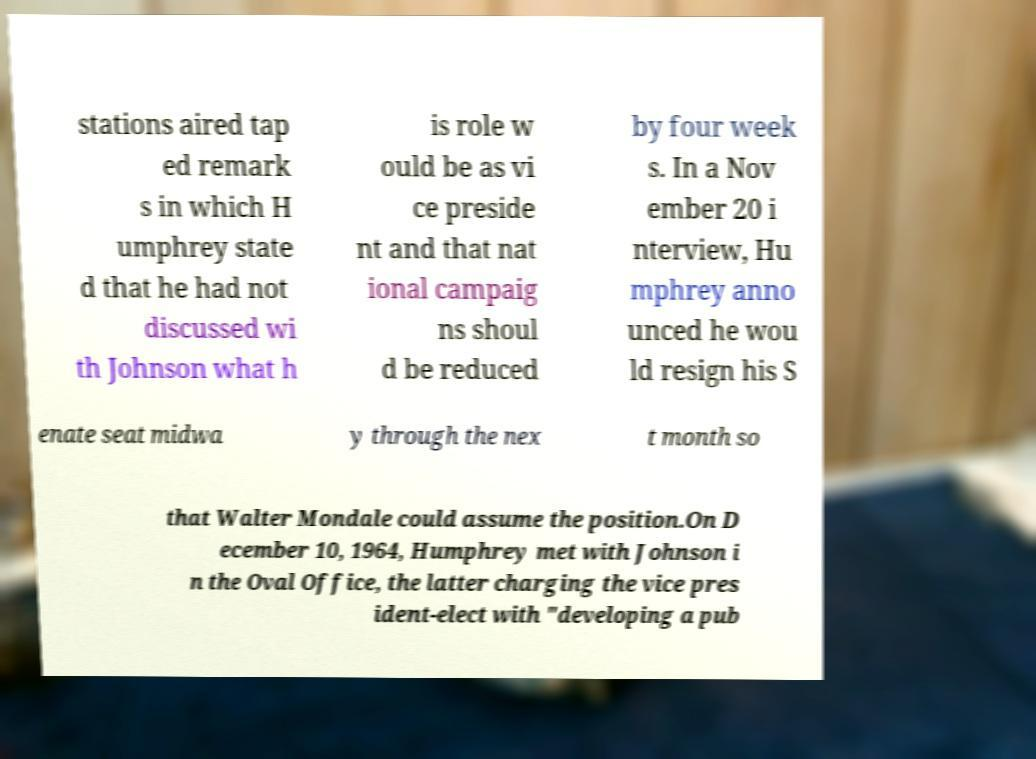Can you read and provide the text displayed in the image?This photo seems to have some interesting text. Can you extract and type it out for me? stations aired tap ed remark s in which H umphrey state d that he had not discussed wi th Johnson what h is role w ould be as vi ce preside nt and that nat ional campaig ns shoul d be reduced by four week s. In a Nov ember 20 i nterview, Hu mphrey anno unced he wou ld resign his S enate seat midwa y through the nex t month so that Walter Mondale could assume the position.On D ecember 10, 1964, Humphrey met with Johnson i n the Oval Office, the latter charging the vice pres ident-elect with "developing a pub 